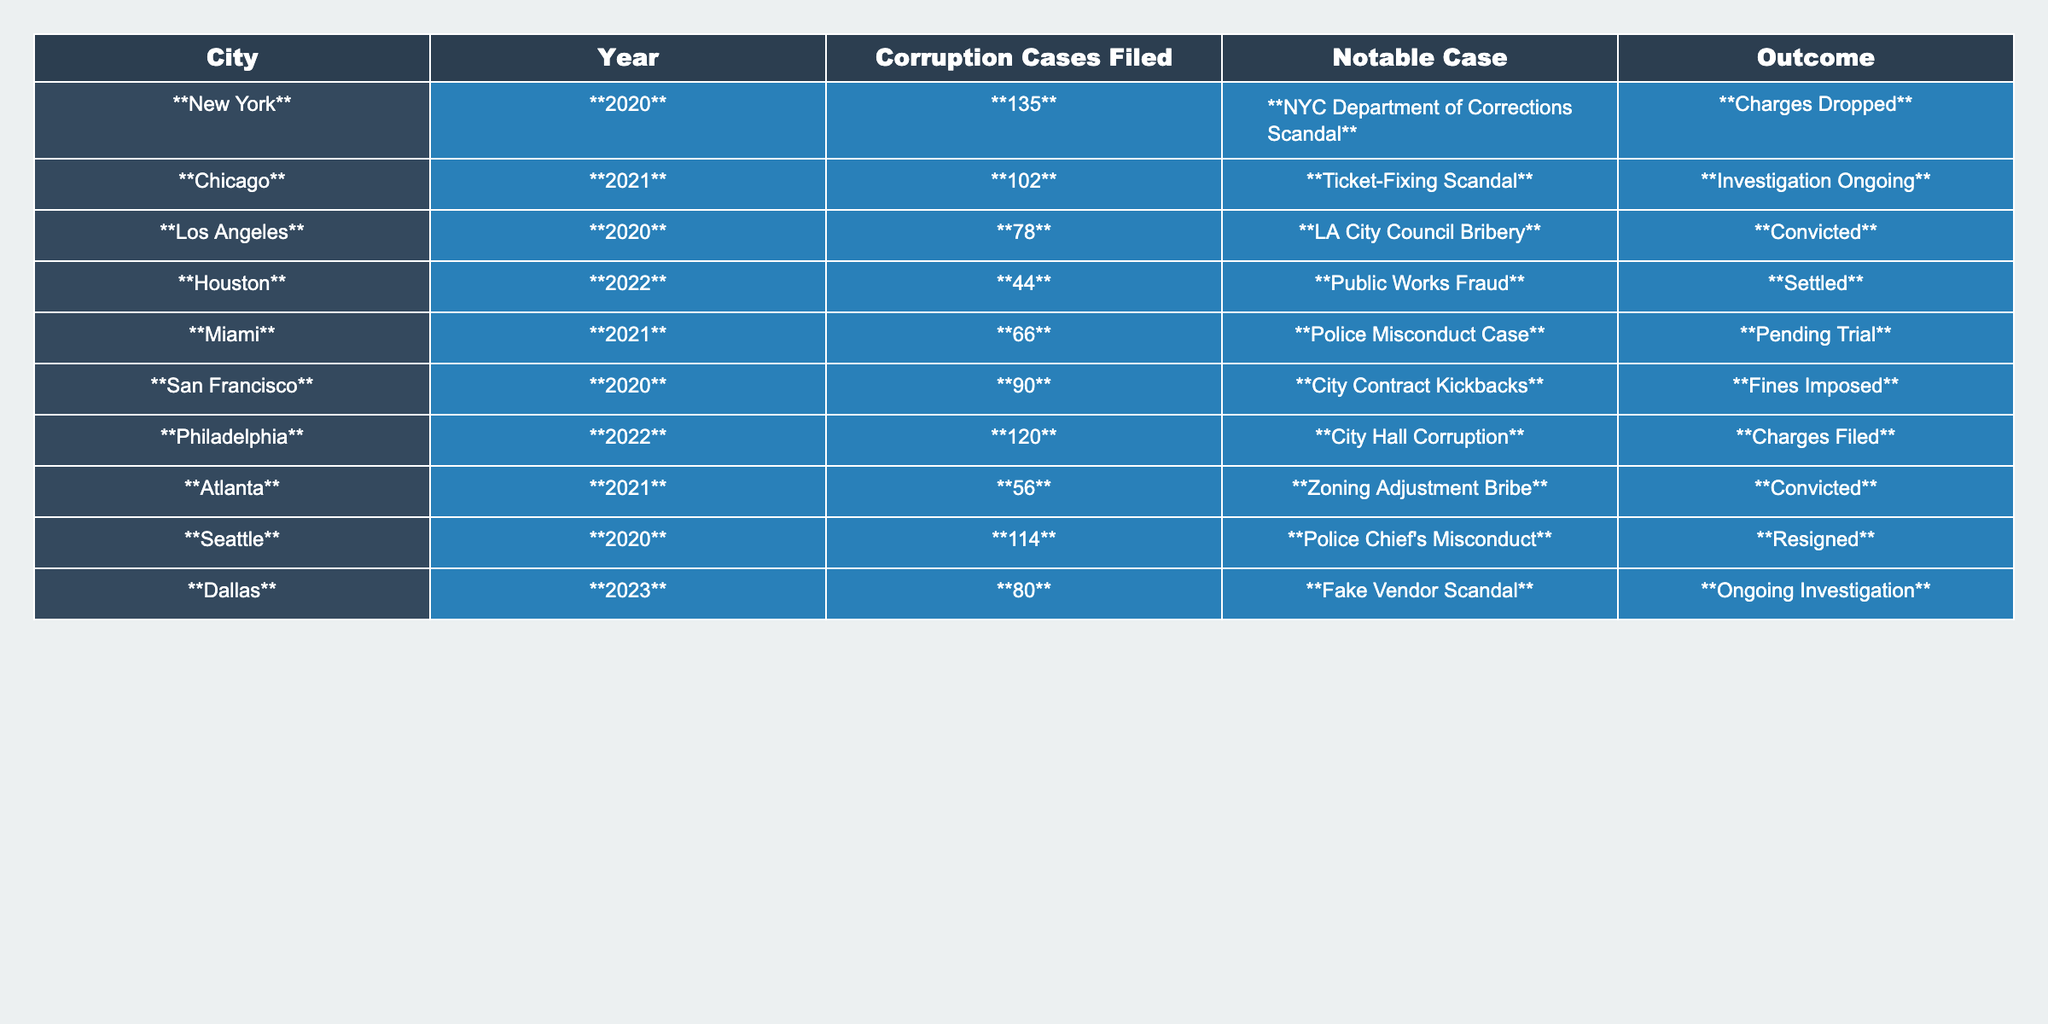What city filed the most corruption cases in 2020? Referring to the table, New York filed **135** cases in 2020, which is the highest for that year.
Answer: New York How many corruption cases were filed in Chicago in 2021? The table indicates that **102** corruption cases were filed in Chicago in 2021.
Answer: 102 What was the outcome of the LA City Council Bribery case? The outcome for the LA City Council Bribery case is listed as **Convicted** in the table.
Answer: Convicted Which city had the least number of corruption cases filed in 2022? Houston had the least with **44** cases filed in 2022 compared to Philadelphia's **120**.
Answer: Houston Was there a corruption case filed in Miami in 2021? Yes, there was a corruption case filed in Miami in 2021 as shown by the **66** cases listed.
Answer: Yes Which city's corruption cases had a pending trial in 2021? The Miami corruption case had a pending trial, as indicated in the table under that city's entry.
Answer: Miami What is the total number of corruption cases filed across all cities in 2020? Adding the cases from New York (**135**), Los Angeles (**78**), San Francisco (**90**), and Seattle (**114**) gives a total of **417** cases for 2020.
Answer: 417 How many more corruption cases were filed in Philadelphia than in Houston in 2022? Philadelphia had **120** cases and Houston had **44** cases in 2022. The difference is **120 - 44 = 76**.
Answer: 76 Are there any ongoing investigations noted in the table? Yes, Dallas has an entry indicating an ongoing investigation regarding the Fake Vendor Scandal.
Answer: Yes What was the most notable case in San Francisco, and what was its outcome? The table states the most notable case in San Francisco was the **City Contract Kickbacks**, which resulted in **Fines Imposed**.
Answer: City Contract Kickbacks, Fines Imposed 